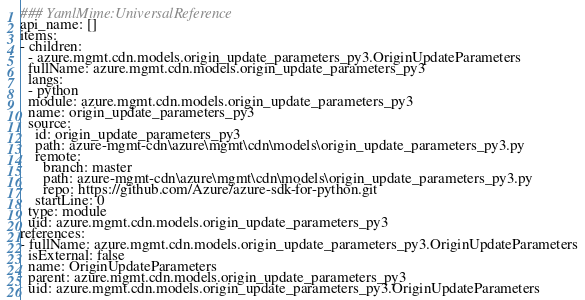Convert code to text. <code><loc_0><loc_0><loc_500><loc_500><_YAML_>### YamlMime:UniversalReference
api_name: []
items:
- children:
  - azure.mgmt.cdn.models.origin_update_parameters_py3.OriginUpdateParameters
  fullName: azure.mgmt.cdn.models.origin_update_parameters_py3
  langs:
  - python
  module: azure.mgmt.cdn.models.origin_update_parameters_py3
  name: origin_update_parameters_py3
  source:
    id: origin_update_parameters_py3
    path: azure-mgmt-cdn\azure\mgmt\cdn\models\origin_update_parameters_py3.py
    remote:
      branch: master
      path: azure-mgmt-cdn\azure\mgmt\cdn\models\origin_update_parameters_py3.py
      repo: https://github.com/Azure/azure-sdk-for-python.git
    startLine: 0
  type: module
  uid: azure.mgmt.cdn.models.origin_update_parameters_py3
references:
- fullName: azure.mgmt.cdn.models.origin_update_parameters_py3.OriginUpdateParameters
  isExternal: false
  name: OriginUpdateParameters
  parent: azure.mgmt.cdn.models.origin_update_parameters_py3
  uid: azure.mgmt.cdn.models.origin_update_parameters_py3.OriginUpdateParameters
</code> 